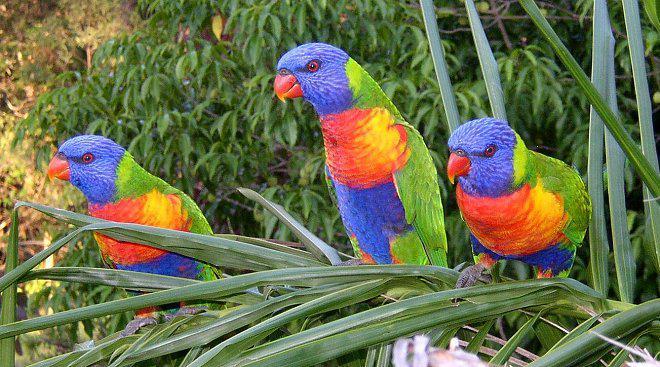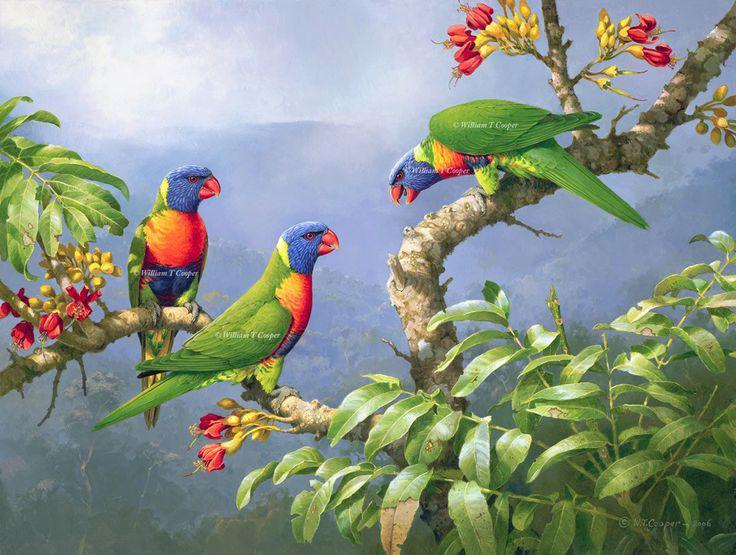The first image is the image on the left, the second image is the image on the right. Given the left and right images, does the statement "The right and left images contain the same number of parrots." hold true? Answer yes or no. Yes. The first image is the image on the left, the second image is the image on the right. Analyze the images presented: Is the assertion "There are no more than three birds" valid? Answer yes or no. No. 